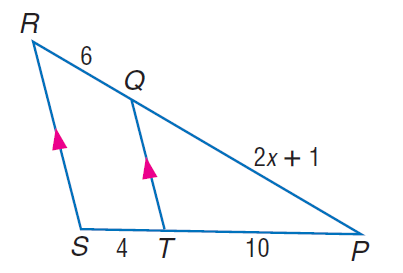Answer the mathemtical geometry problem and directly provide the correct option letter.
Question: Find x.
Choices: A: 7 B: 9 C: 12 D: 15 A 